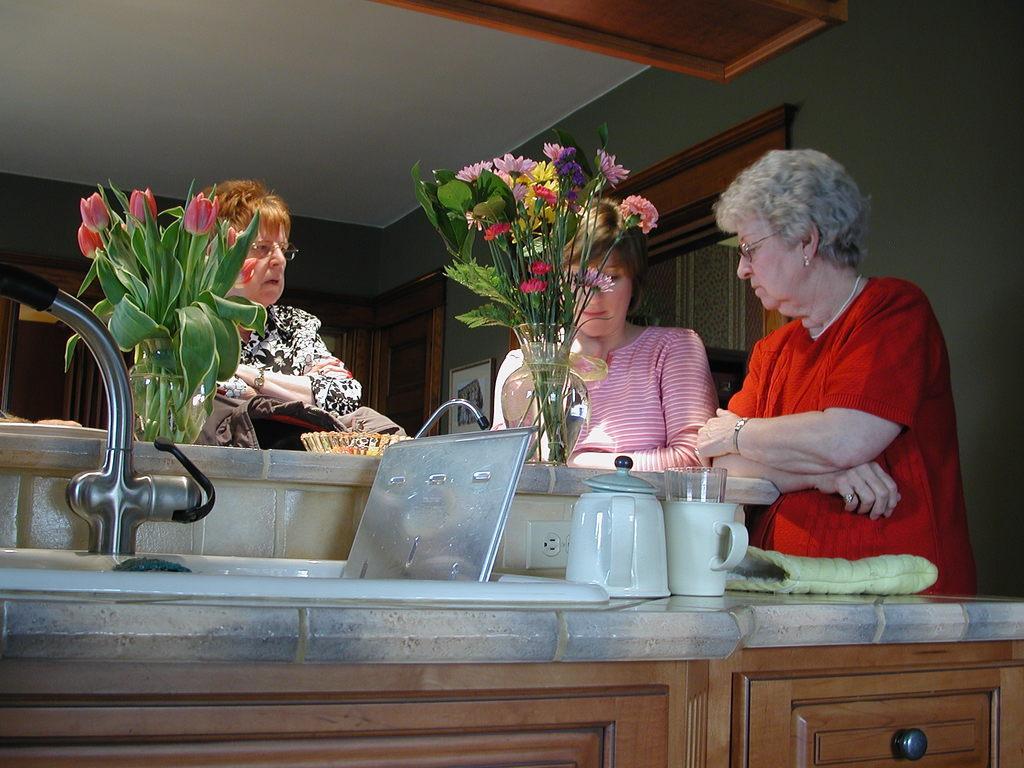How would you summarize this image in a sentence or two? In this picture I can see few woman and I can see couple of flower pots and I can see a wash basin and a glove on the counter top and I can see a cup and a kettle and I can see doors and cupboards 